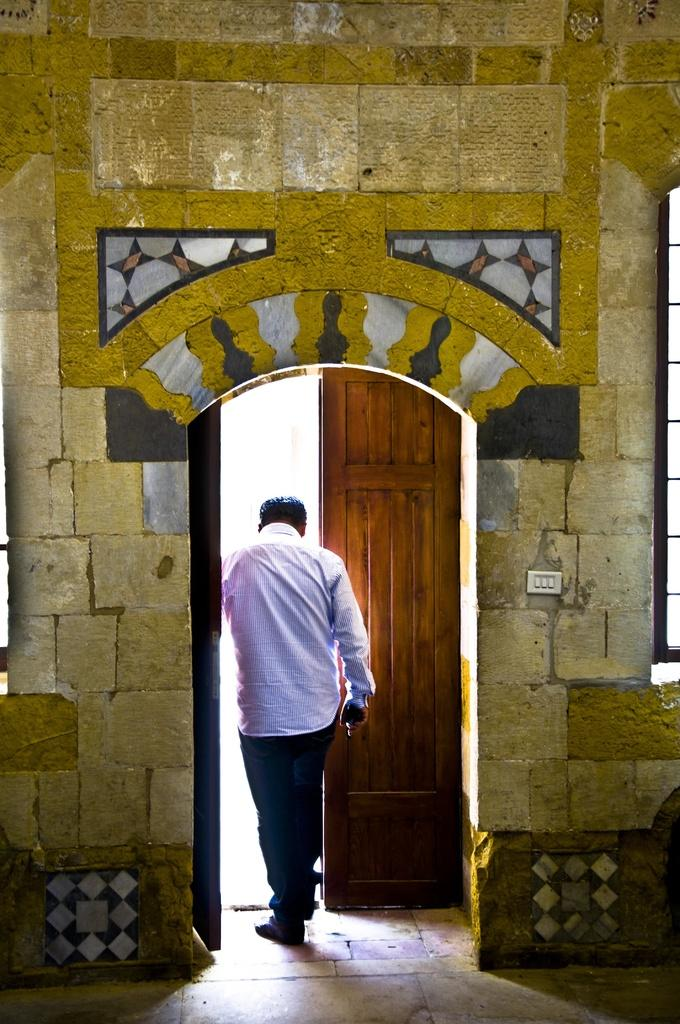What is the person in the image doing? There is a person walking in the image. What architectural feature can be seen in the image? There is a door and a wall in the image. What device is present in the image? There is a switchboard in the image. What can be seen on the right side of the image? There is a window on the right side of the image. Where is the yak grazing in the image? There is no yak present in the image. Can you describe the bathing facilities in the image? There are no bathing facilities visible in the image. 